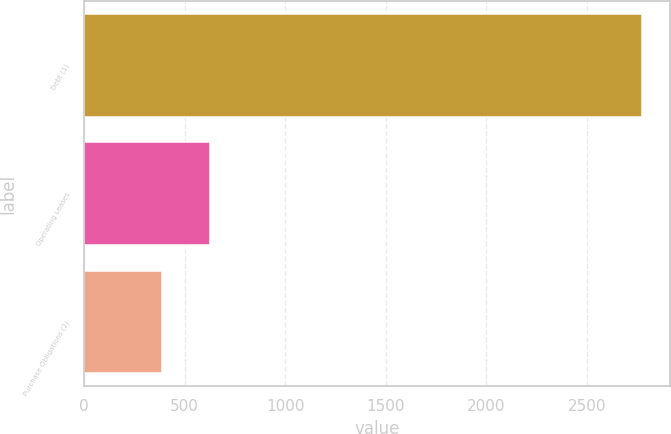<chart> <loc_0><loc_0><loc_500><loc_500><bar_chart><fcel>Debt (1)<fcel>Operating Leases<fcel>Purchase Obligations (2)<nl><fcel>2773<fcel>624.7<fcel>386<nl></chart> 